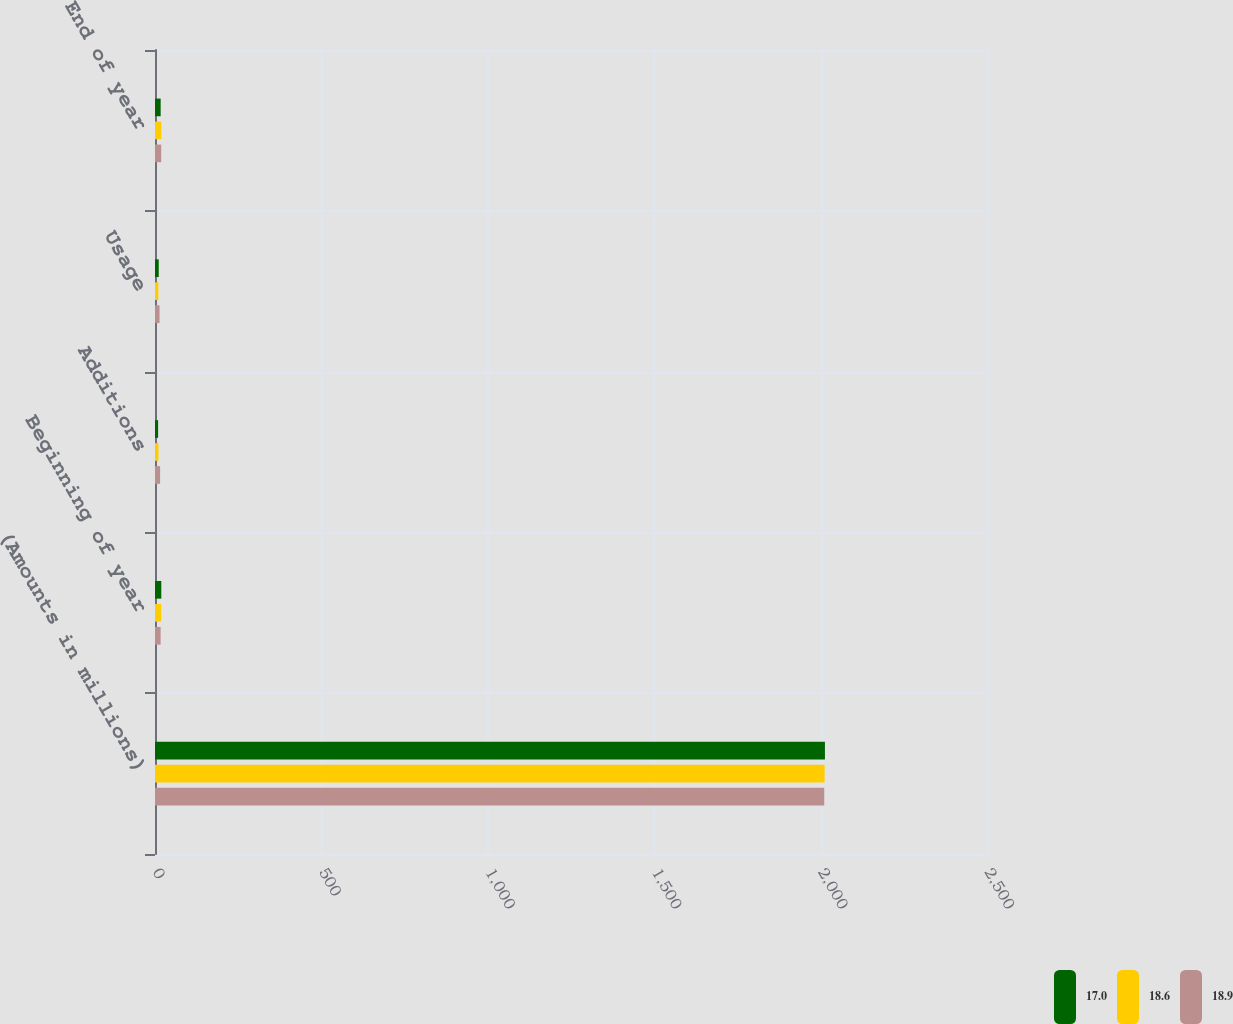Convert chart. <chart><loc_0><loc_0><loc_500><loc_500><stacked_bar_chart><ecel><fcel>(Amounts in millions)<fcel>Beginning of year<fcel>Additions<fcel>Usage<fcel>End of year<nl><fcel>17<fcel>2013<fcel>18.9<fcel>9.3<fcel>11.2<fcel>17<nl><fcel>18.6<fcel>2012<fcel>18.6<fcel>10.4<fcel>10.1<fcel>18.9<nl><fcel>18.9<fcel>2011<fcel>16.9<fcel>15.3<fcel>13.6<fcel>18.6<nl></chart> 